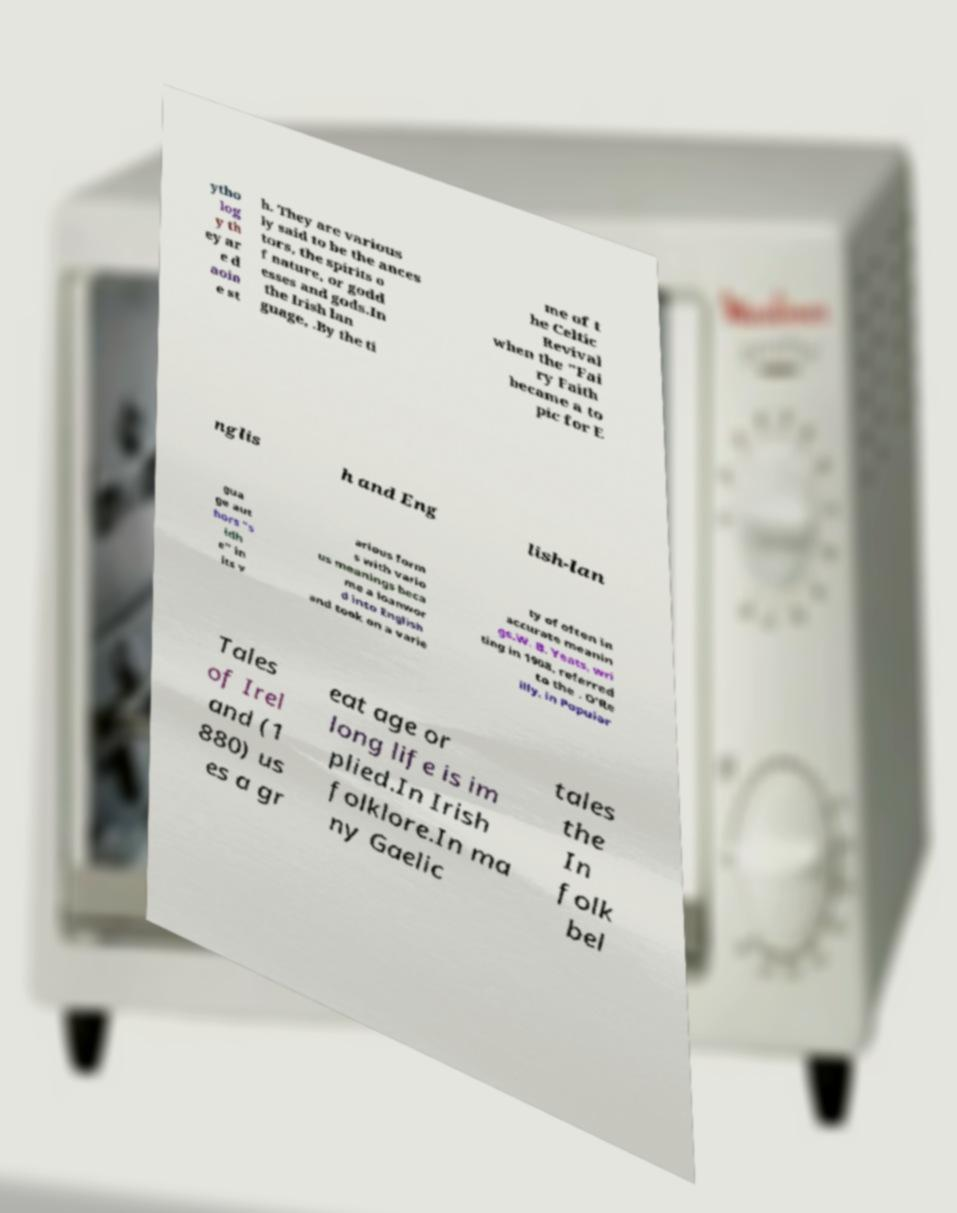Can you read and provide the text displayed in the image?This photo seems to have some interesting text. Can you extract and type it out for me? ytho log y th ey ar e d aoin e st h. They are various ly said to be the ances tors, the spirits o f nature, or godd esses and gods.In the Irish lan guage, .By the ti me of t he Celtic Revival when the "Fai ry Faith became a to pic for E nglis h and Eng lish-lan gua ge aut hors "s idh e" in its v arious form s with vario us meanings beca me a loanwor d into English and took on a varie ty of often in accurate meanin gs.W. B. Yeats, wri ting in 1908, referred to the . O'Re illy, in Popular Tales of Irel and (1 880) us es a gr eat age or long life is im plied.In Irish folklore.In ma ny Gaelic tales the In folk bel 